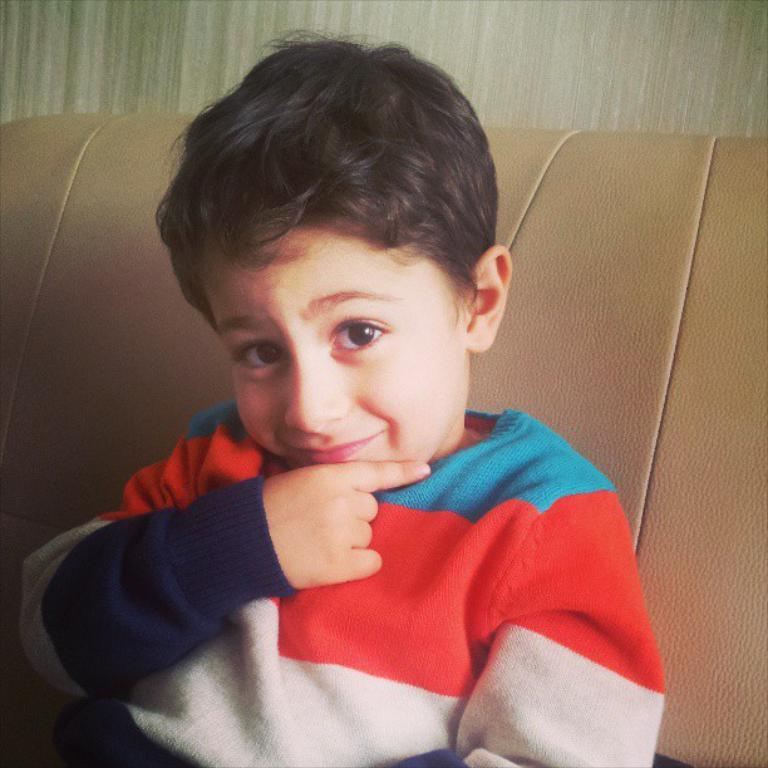Who is in the image? There is a boy in the image. What is the boy doing in the image? The boy is sitting on a sofa. What can be seen behind the boy in the image? There is a wall visible in the background of the image. What type of test is the boy taking in the image? There is no test present in the image; the boy is simply sitting on a sofa. 